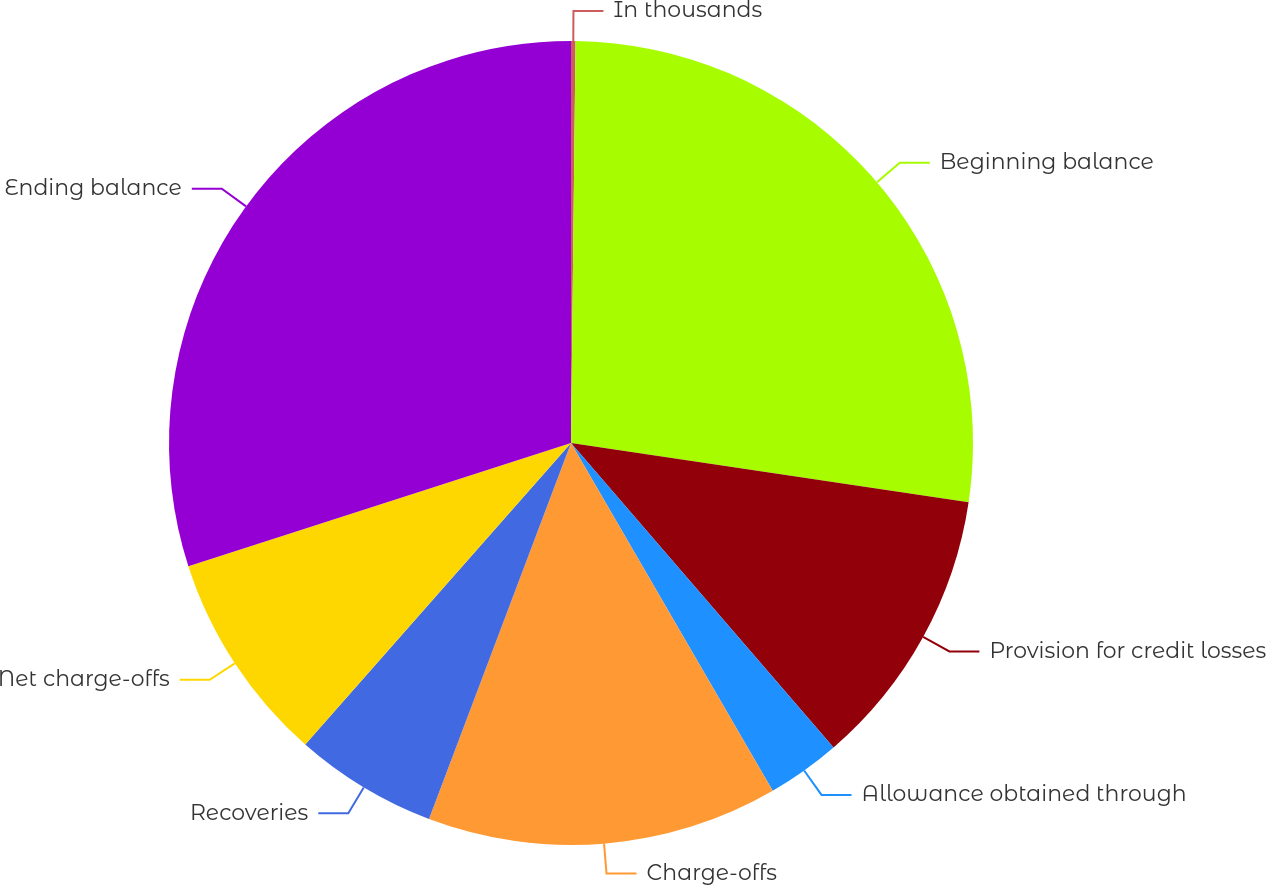Convert chart. <chart><loc_0><loc_0><loc_500><loc_500><pie_chart><fcel>In thousands<fcel>Beginning balance<fcel>Provision for credit losses<fcel>Allowance obtained through<fcel>Charge-offs<fcel>Recoveries<fcel>Net charge-offs<fcel>Ending balance<nl><fcel>0.18%<fcel>27.17%<fcel>11.32%<fcel>2.96%<fcel>14.11%<fcel>5.75%<fcel>8.54%<fcel>29.96%<nl></chart> 